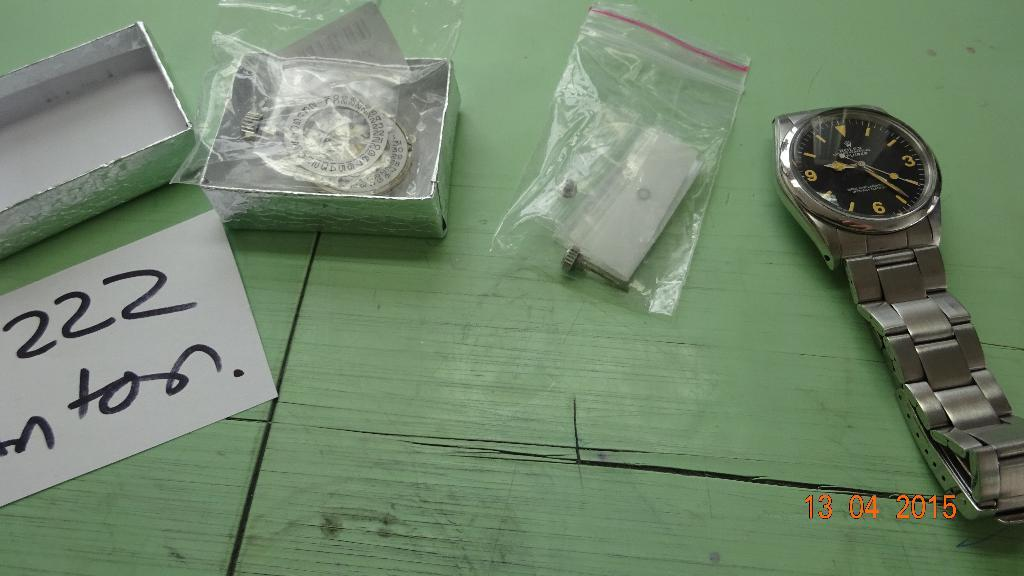<image>
Present a compact description of the photo's key features. a silver watch on a green desk  with a piece of paper reading 222 